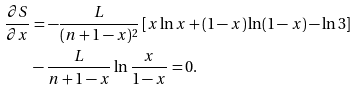<formula> <loc_0><loc_0><loc_500><loc_500>\frac { \partial S } { \partial x } & = - \frac { L } { ( n + 1 - x ) ^ { 2 } } \left [ x \ln x + ( 1 - x ) \ln ( 1 - x ) - { \ln 3 } \right ] \\ & - \frac { L } { n + 1 - x } \ln \frac { x } { 1 - x } = 0 .</formula> 